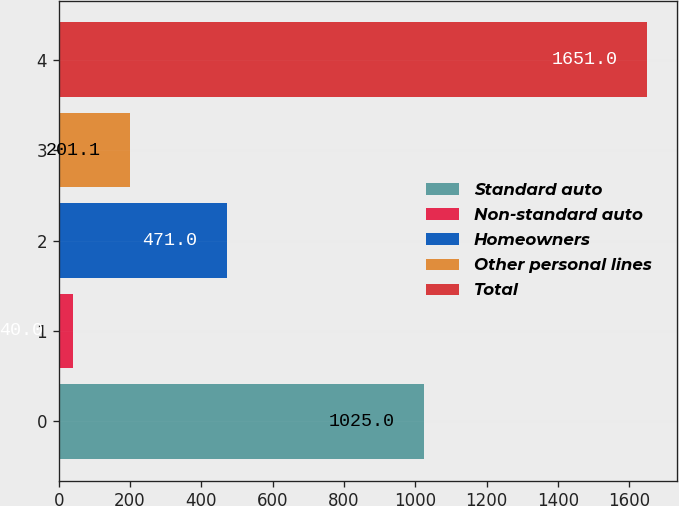Convert chart. <chart><loc_0><loc_0><loc_500><loc_500><bar_chart><fcel>Standard auto<fcel>Non-standard auto<fcel>Homeowners<fcel>Other personal lines<fcel>Total<nl><fcel>1025<fcel>40<fcel>471<fcel>201.1<fcel>1651<nl></chart> 